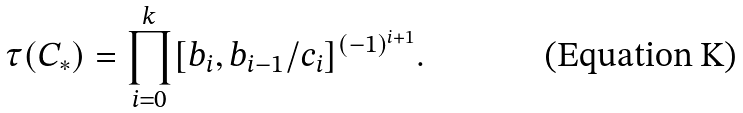Convert formula to latex. <formula><loc_0><loc_0><loc_500><loc_500>\tau ( C _ { * } ) = \prod _ { i = 0 } ^ { k } [ b _ { i } , b _ { i - 1 } / c _ { i } ] ^ { ( - 1 ) ^ { i + 1 } } .</formula> 